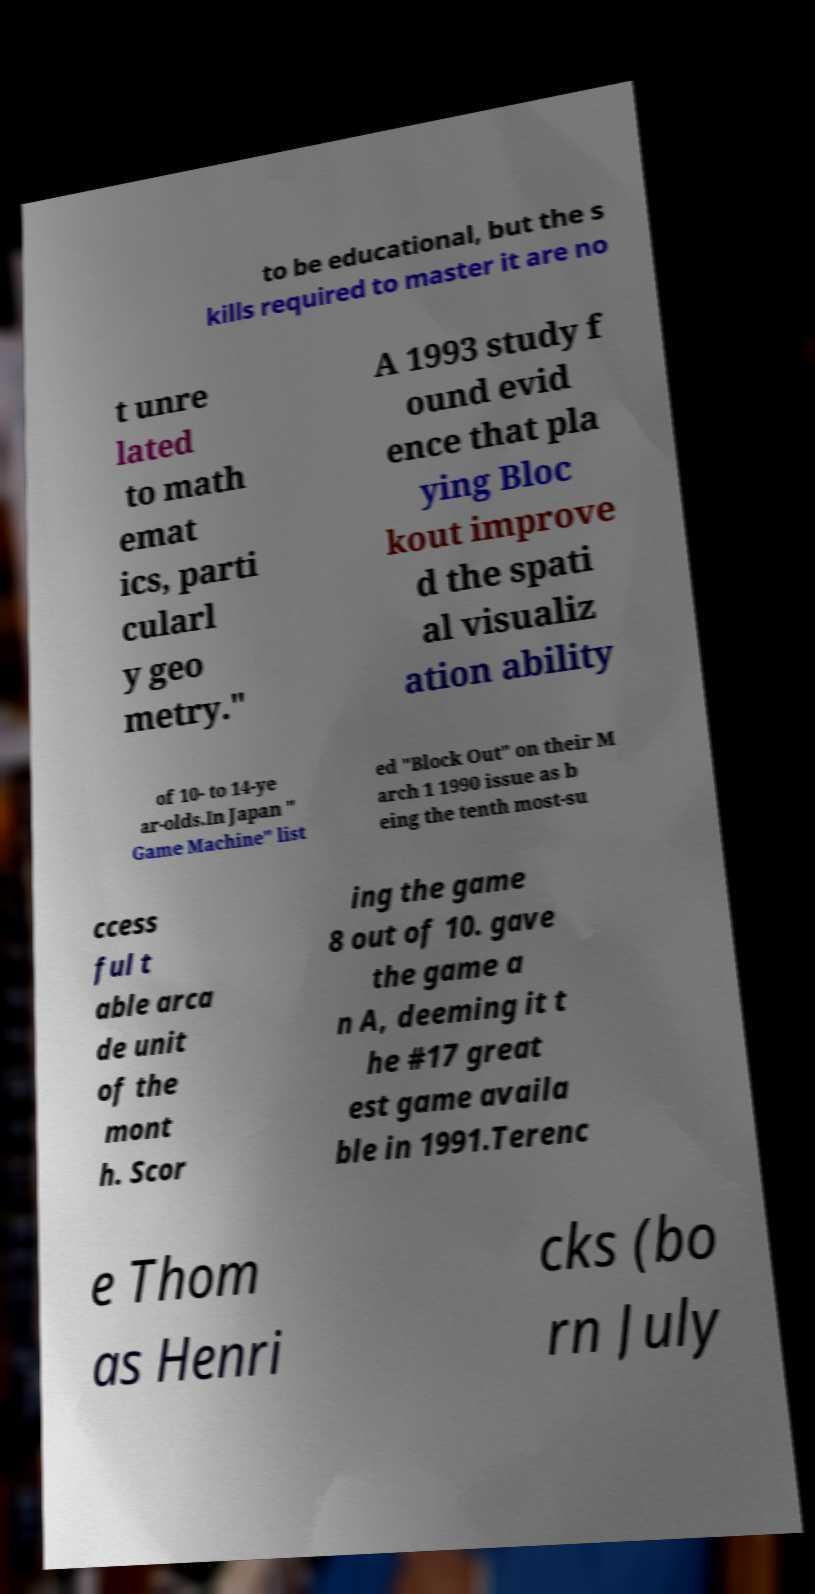There's text embedded in this image that I need extracted. Can you transcribe it verbatim? to be educational, but the s kills required to master it are no t unre lated to math emat ics, parti cularl y geo metry." A 1993 study f ound evid ence that pla ying Bloc kout improve d the spati al visualiz ation ability of 10- to 14-ye ar-olds.In Japan " Game Machine" list ed "Block Out" on their M arch 1 1990 issue as b eing the tenth most-su ccess ful t able arca de unit of the mont h. Scor ing the game 8 out of 10. gave the game a n A, deeming it t he #17 great est game availa ble in 1991.Terenc e Thom as Henri cks (bo rn July 